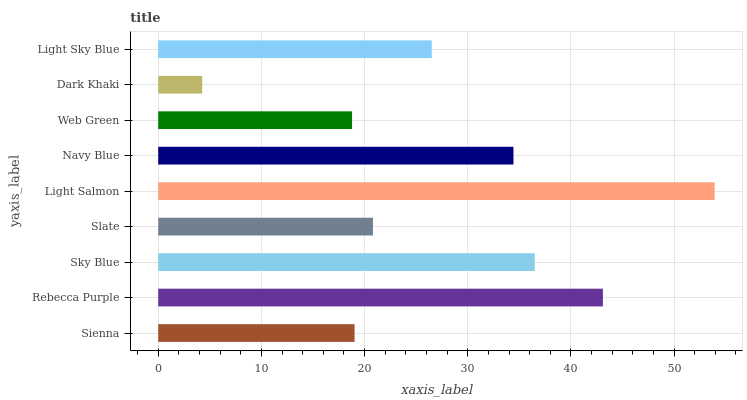Is Dark Khaki the minimum?
Answer yes or no. Yes. Is Light Salmon the maximum?
Answer yes or no. Yes. Is Rebecca Purple the minimum?
Answer yes or no. No. Is Rebecca Purple the maximum?
Answer yes or no. No. Is Rebecca Purple greater than Sienna?
Answer yes or no. Yes. Is Sienna less than Rebecca Purple?
Answer yes or no. Yes. Is Sienna greater than Rebecca Purple?
Answer yes or no. No. Is Rebecca Purple less than Sienna?
Answer yes or no. No. Is Light Sky Blue the high median?
Answer yes or no. Yes. Is Light Sky Blue the low median?
Answer yes or no. Yes. Is Slate the high median?
Answer yes or no. No. Is Sienna the low median?
Answer yes or no. No. 